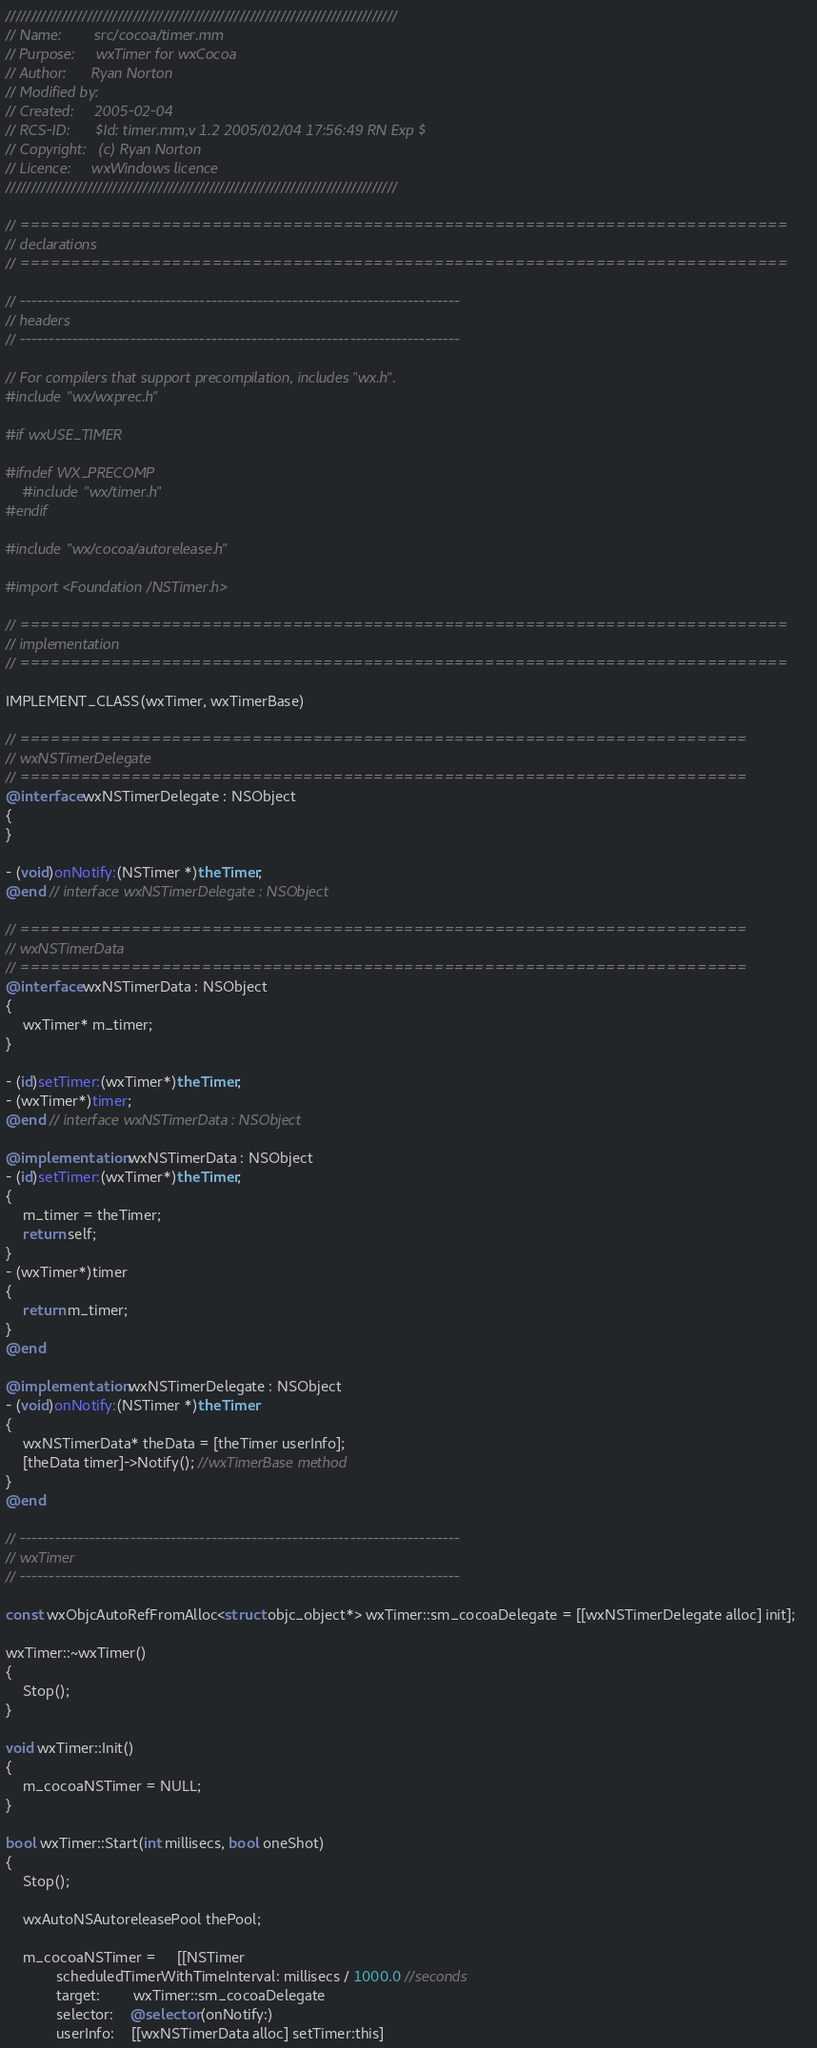Convert code to text. <code><loc_0><loc_0><loc_500><loc_500><_ObjectiveC_>/////////////////////////////////////////////////////////////////////////////
// Name:        src/cocoa/timer.mm
// Purpose:     wxTimer for wxCocoa
// Author:      Ryan Norton
// Modified by:
// Created:     2005-02-04
// RCS-ID:      $Id: timer.mm,v 1.2 2005/02/04 17:56:49 RN Exp $
// Copyright:   (c) Ryan Norton
// Licence:     wxWindows licence
/////////////////////////////////////////////////////////////////////////////

// ============================================================================
// declarations
// ============================================================================

// ----------------------------------------------------------------------------
// headers
// ----------------------------------------------------------------------------

// For compilers that support precompilation, includes "wx.h".
#include "wx/wxprec.h"

#if wxUSE_TIMER

#ifndef WX_PRECOMP
    #include "wx/timer.h"
#endif

#include "wx/cocoa/autorelease.h"

#import <Foundation/NSTimer.h>

// ============================================================================
// implementation
// ============================================================================

IMPLEMENT_CLASS(wxTimer, wxTimerBase)

// ========================================================================
// wxNSTimerDelegate
// ========================================================================
@interface wxNSTimerDelegate : NSObject
{
}

- (void)onNotify:(NSTimer *)theTimer;
@end // interface wxNSTimerDelegate : NSObject

// ========================================================================
// wxNSTimerData
// ========================================================================
@interface wxNSTimerData : NSObject
{
    wxTimer* m_timer;
}

- (id)setTimer:(wxTimer*)theTimer;
- (wxTimer*)timer;
@end // interface wxNSTimerData : NSObject

@implementation wxNSTimerData : NSObject
- (id)setTimer:(wxTimer*)theTimer;
{
    m_timer = theTimer;
    return self;
}
- (wxTimer*)timer
{
    return m_timer;
}
@end 

@implementation wxNSTimerDelegate : NSObject
- (void)onNotify:(NSTimer *)theTimer
{
    wxNSTimerData* theData = [theTimer userInfo];
    [theData timer]->Notify(); //wxTimerBase method
}
@end 

// ----------------------------------------------------------------------------
// wxTimer
// ----------------------------------------------------------------------------

const wxObjcAutoRefFromAlloc<struct objc_object*> wxTimer::sm_cocoaDelegate = [[wxNSTimerDelegate alloc] init];

wxTimer::~wxTimer()
{
    Stop();
}

void wxTimer::Init()
{
    m_cocoaNSTimer = NULL;
}

bool wxTimer::Start(int millisecs, bool oneShot)
{
    Stop();
    
    wxAutoNSAutoreleasePool thePool;

    m_cocoaNSTimer =     [[NSTimer 
            scheduledTimerWithTimeInterval: millisecs / 1000.0 //seconds
            target:		wxTimer::sm_cocoaDelegate
            selector:	@selector(onNotify:) 
            userInfo:	[[wxNSTimerData alloc] setTimer:this]</code> 